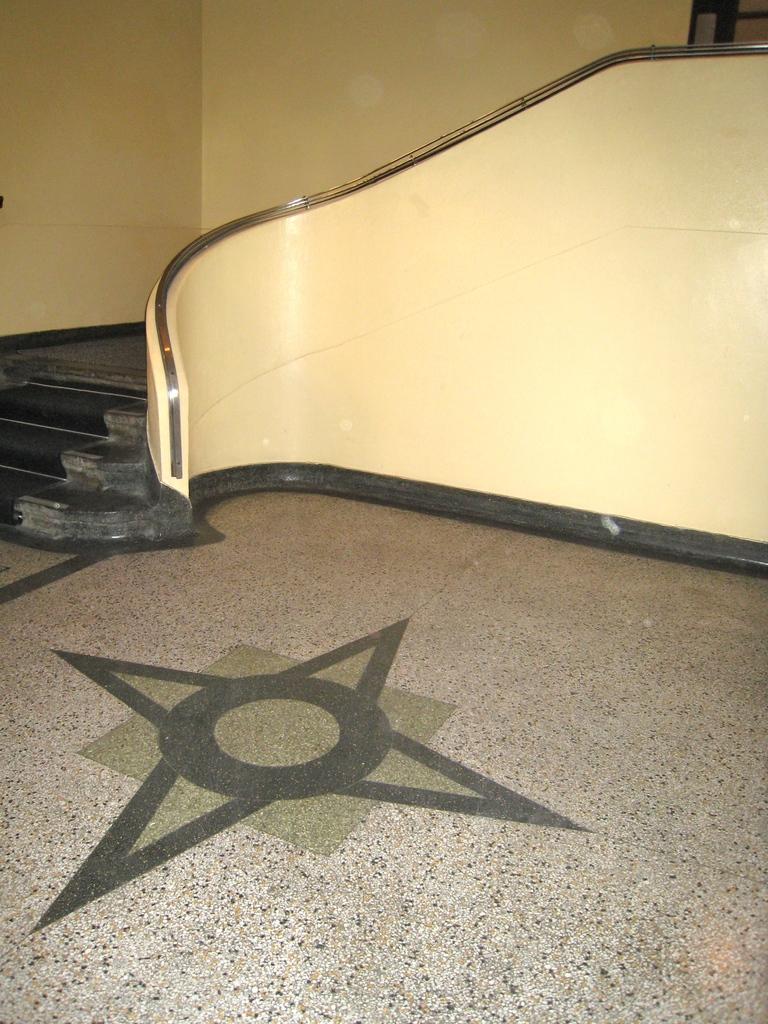Describe this image in one or two sentences. The picture is taken in a room. In the foreground of the picture there is a design on the tiles. On the left there is a staircase. In the center it is well. In the background the wall is painted yellow. 